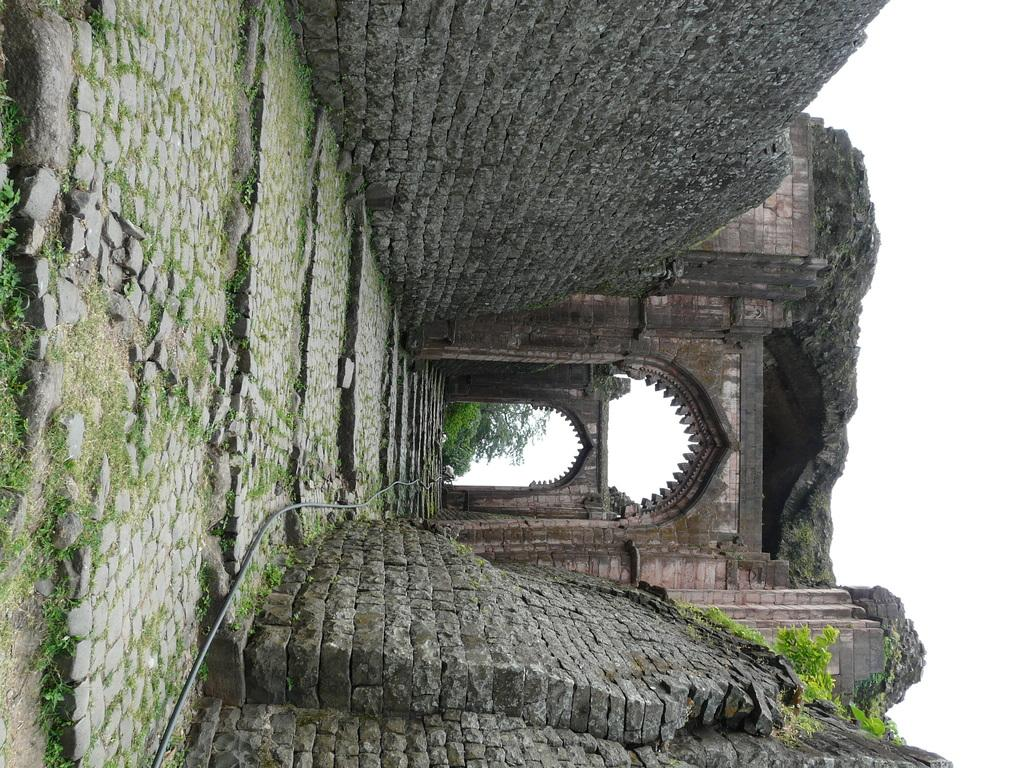What type of structures can be seen in the image? There are walls and arches in the image. What type of vegetation is present in the image? There are plants and trees in the image. What part of the natural environment is visible in the image? The sky is visible in the image. Where is the sofa located in the image? There is no sofa present in the image. What type of bushes can be seen in the image? There are no bushes mentioned in the provided facts, only plants and trees are mentioned. 